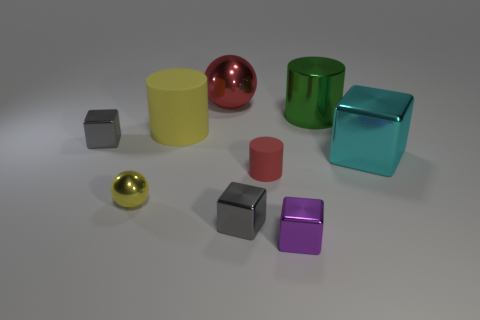What is the color of the big metallic object that is both to the left of the large cyan object and in front of the big red metal sphere? The color of the large metallic object situated to the left of the large cyan box and in front of the big red metal sphere is green. This object appears to have a reflective surface and a cubic shape, similar to the other colorful geometric shapes arranged in the image. 